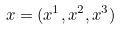<formula> <loc_0><loc_0><loc_500><loc_500>x = ( x ^ { 1 } , x ^ { 2 } , x ^ { 3 } )</formula> 